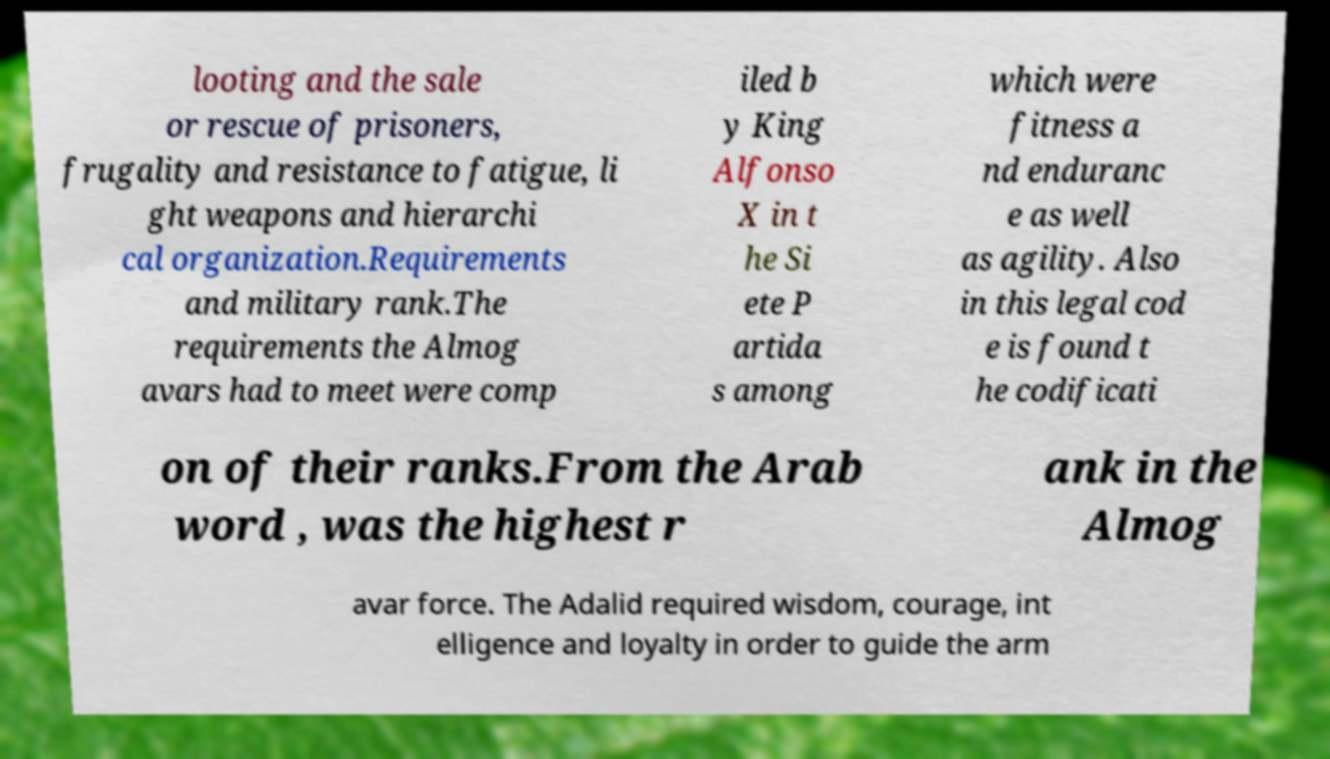Could you assist in decoding the text presented in this image and type it out clearly? looting and the sale or rescue of prisoners, frugality and resistance to fatigue, li ght weapons and hierarchi cal organization.Requirements and military rank.The requirements the Almog avars had to meet were comp iled b y King Alfonso X in t he Si ete P artida s among which were fitness a nd enduranc e as well as agility. Also in this legal cod e is found t he codificati on of their ranks.From the Arab word , was the highest r ank in the Almog avar force. The Adalid required wisdom, courage, int elligence and loyalty in order to guide the arm 